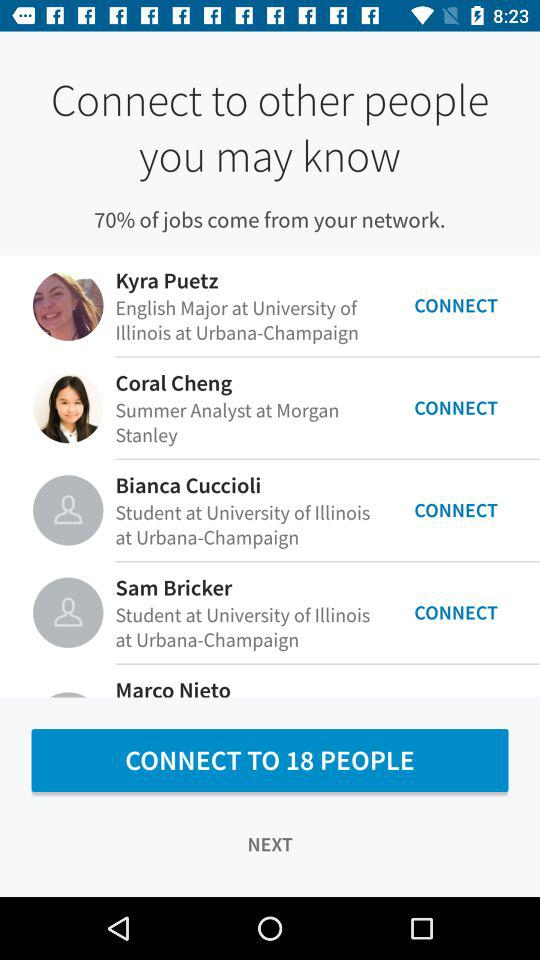What percentage of jobs come from your network? The percentage of jobs that come from your network is 70. 